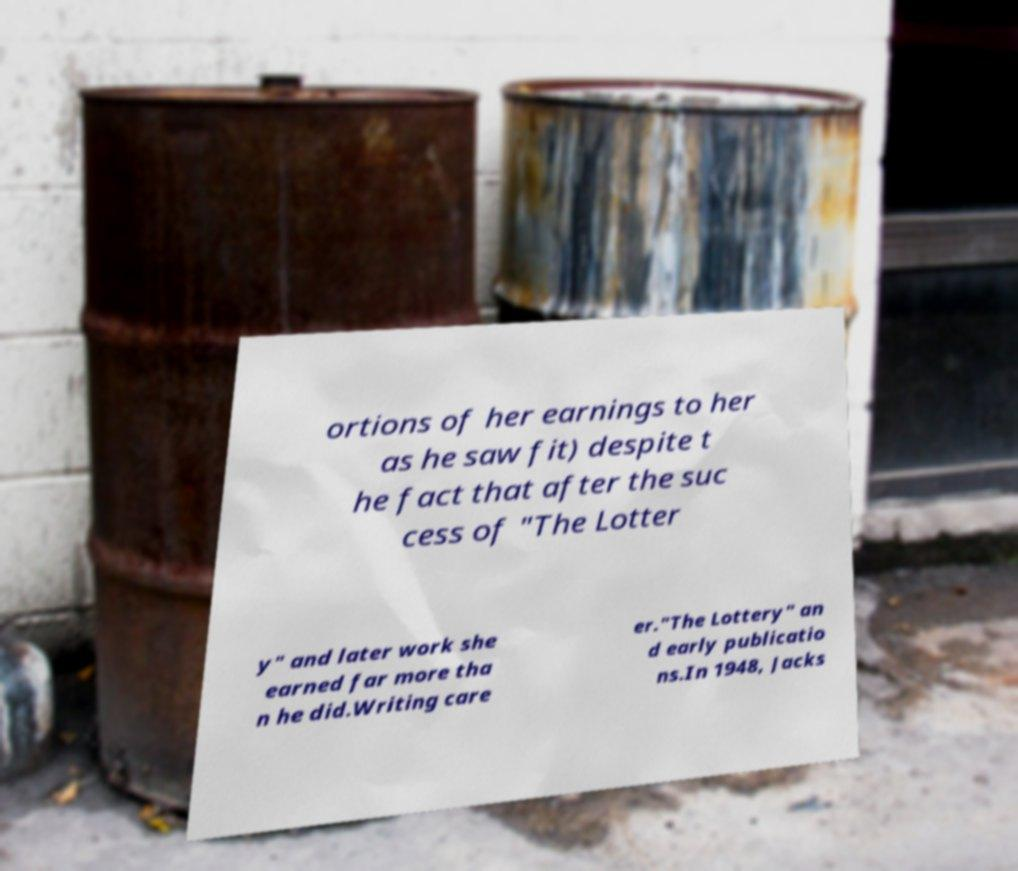Could you assist in decoding the text presented in this image and type it out clearly? ortions of her earnings to her as he saw fit) despite t he fact that after the suc cess of "The Lotter y" and later work she earned far more tha n he did.Writing care er."The Lottery" an d early publicatio ns.In 1948, Jacks 